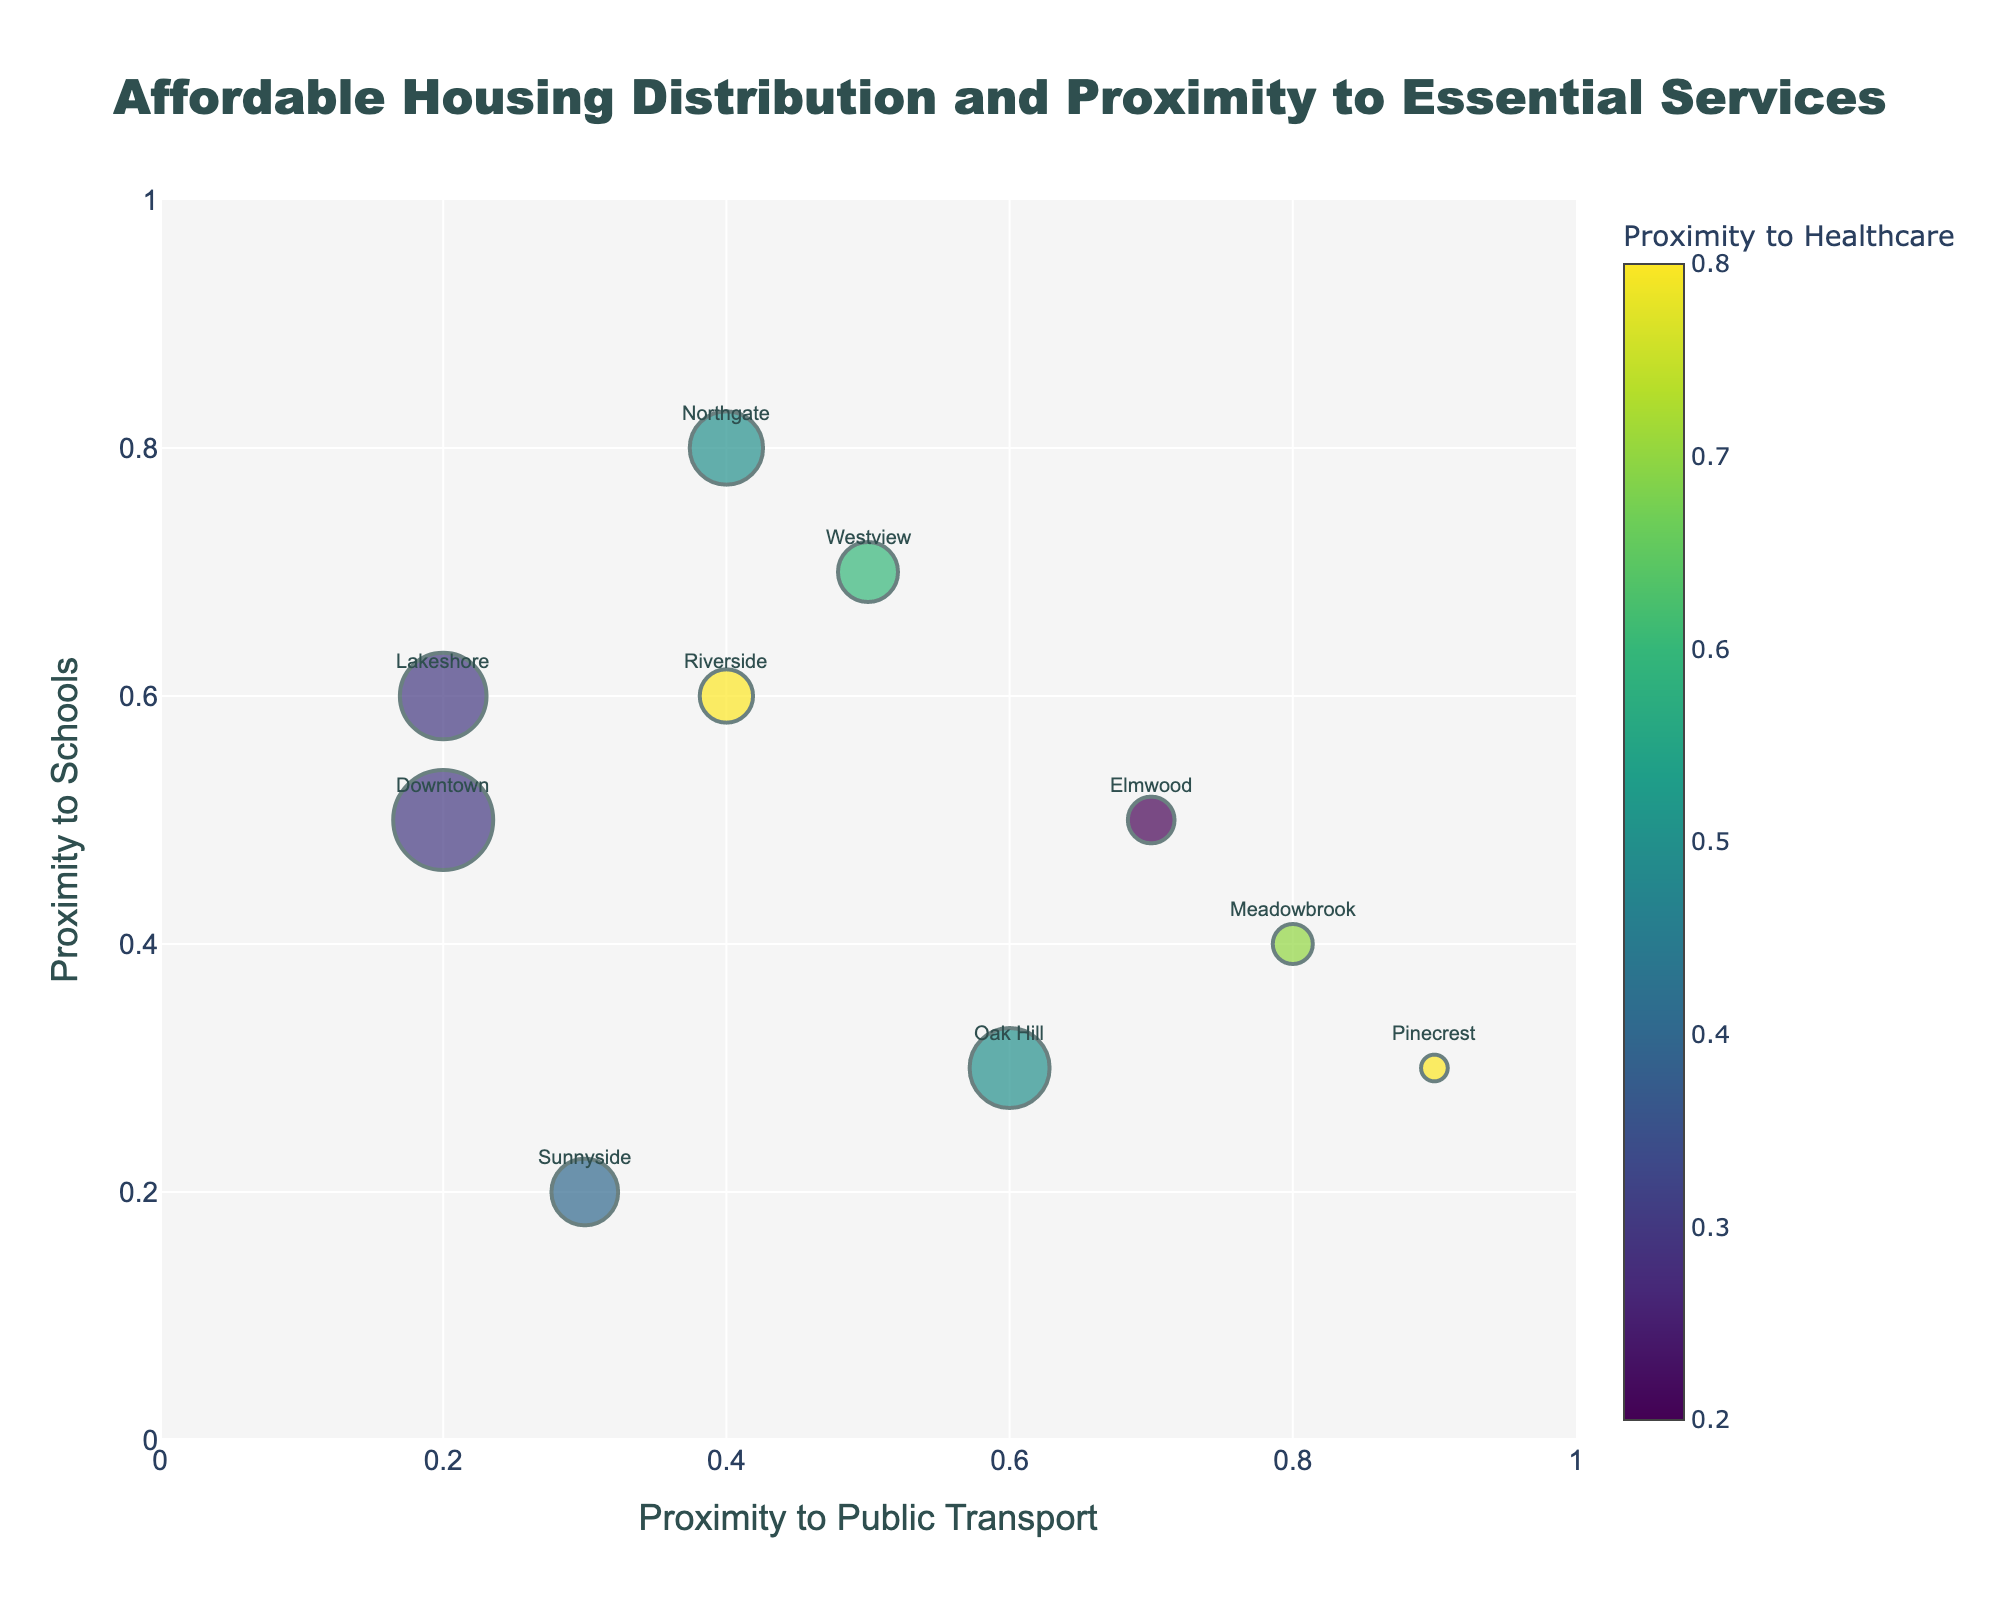What is the title of the plot? The title is typically found at the top of the plot. In this case, it is clearly mentioned in the specification of the `fig.update_layout`.
Answer: Affordable Housing Distribution and Proximity to Essential Services How many neighborhoods are depicted in the plot? Each neighborhood is represented by a data point in the plot. Here, 10 neighborhoods are given in the data.
Answer: 10 Which neighborhood has the highest proximity to public transport? By looking at the x-axis, identify the point farthest to the right. The data suggests Pinecrest has the highest proximity to public transport with a value of 0.9.
Answer: Pinecrest Which neighborhood is closest to schools? By examining the y-axis and finding the highest point, Northgate is the closest to schools with a value of 0.8.
Answer: Northgate What is the relationship between affordable units and their proximity to healthcare for Downtown? Downtown has 150 affordable units, and based on the color scale for proximity to healthcare, it is represented by a color value of 0.3.
Answer: 150 units and 0.3 proximity Which neighborhoods have a higher proximity to public transport than Sunnyside, but less than Westview? Sunnyside has a proximity value of 0.3, and Westview has 0.5. The neighborhoods between 0.3 and 0.5 are Riverside and Northgate.
Answer: Riverside, Northgate What is the approximate size of the marker for Oak Hill? The marker size is proportional to the number of affordable units. Oak Hill has 120 units, so its size will be 120/3 = 40.
Answer: 40 Does a higher proximity to public transport correlate with a higher number of affordable units? By comparing the x-axis (public transport proximity) with the marker sizes, check if larger markers (more units) are aligned with higher x-values. Pinecrest has the highest proximity but the least units, suggesting no clear correlation.
Answer: No clear correlation Which neighborhood has the lowest proximity to healthcare, and what is its affordable unit count? Identify the color on the color scale closest to zero. Elmwood's proximity to healthcare is 0.2, with 70 affordable units.
Answer: Elmwood, 70 units Is there any neighborhood that has an equal proximity value for public transport and schools? Compare the x and y values for each neighborhood. Sunnyside has equal proximity values of 0.3 for both public transport and schools.
Answer: Sunnyside 